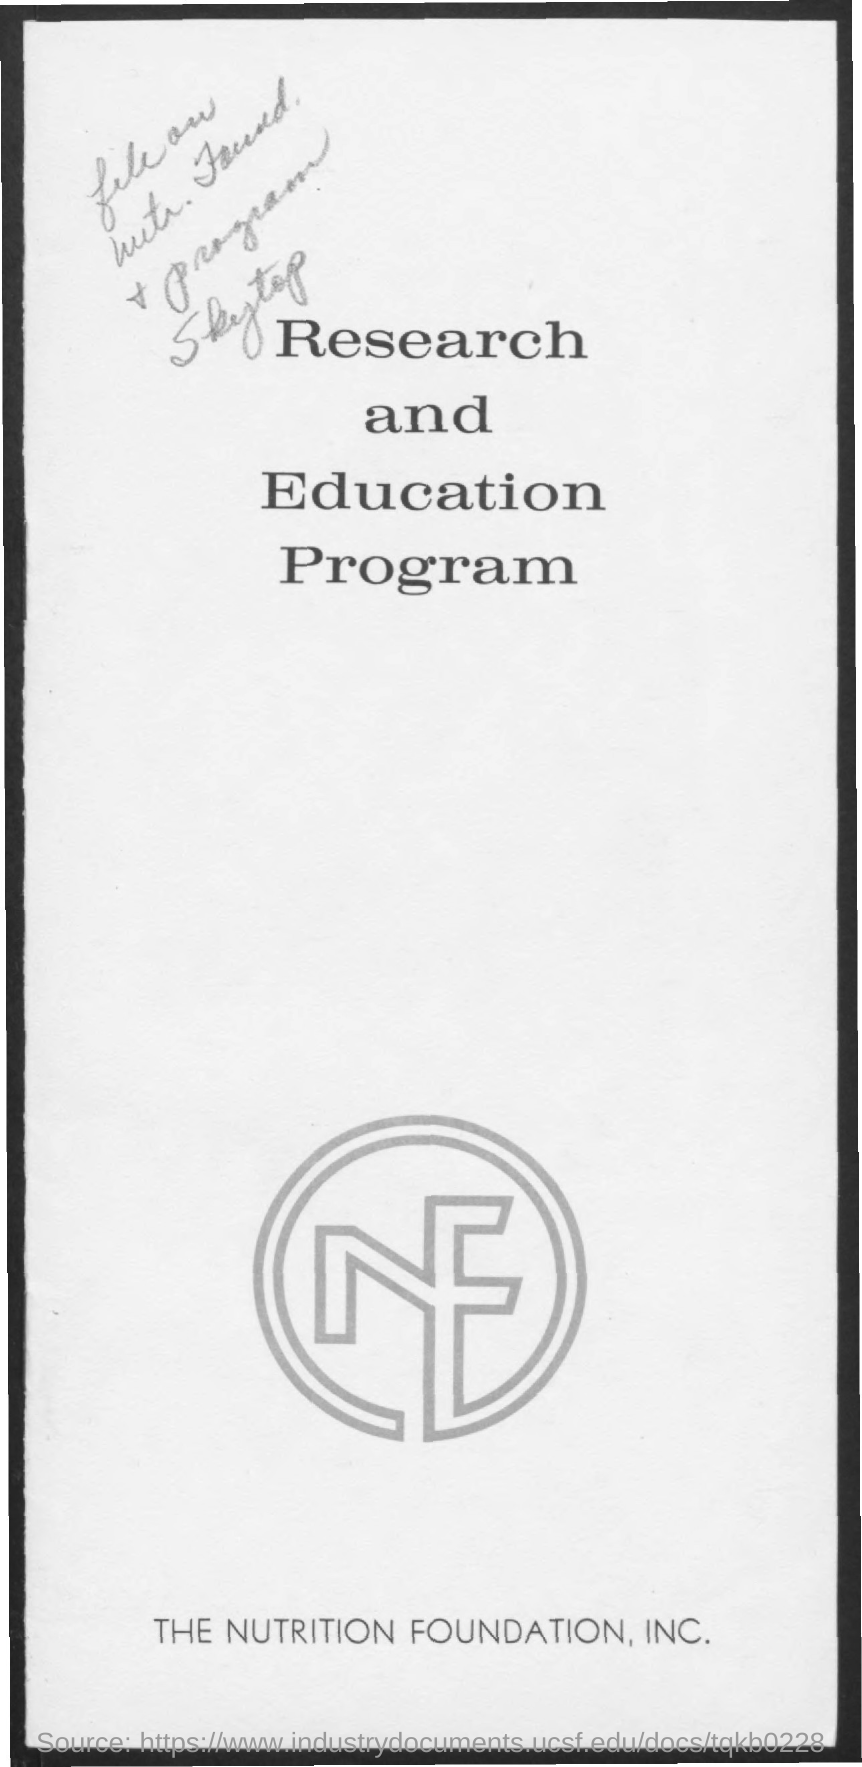What is the title of the document?
Offer a very short reply. Research and education program. Which organizations name is given at the bottom?
Make the answer very short. The Nutrition Foundation, Inc. 